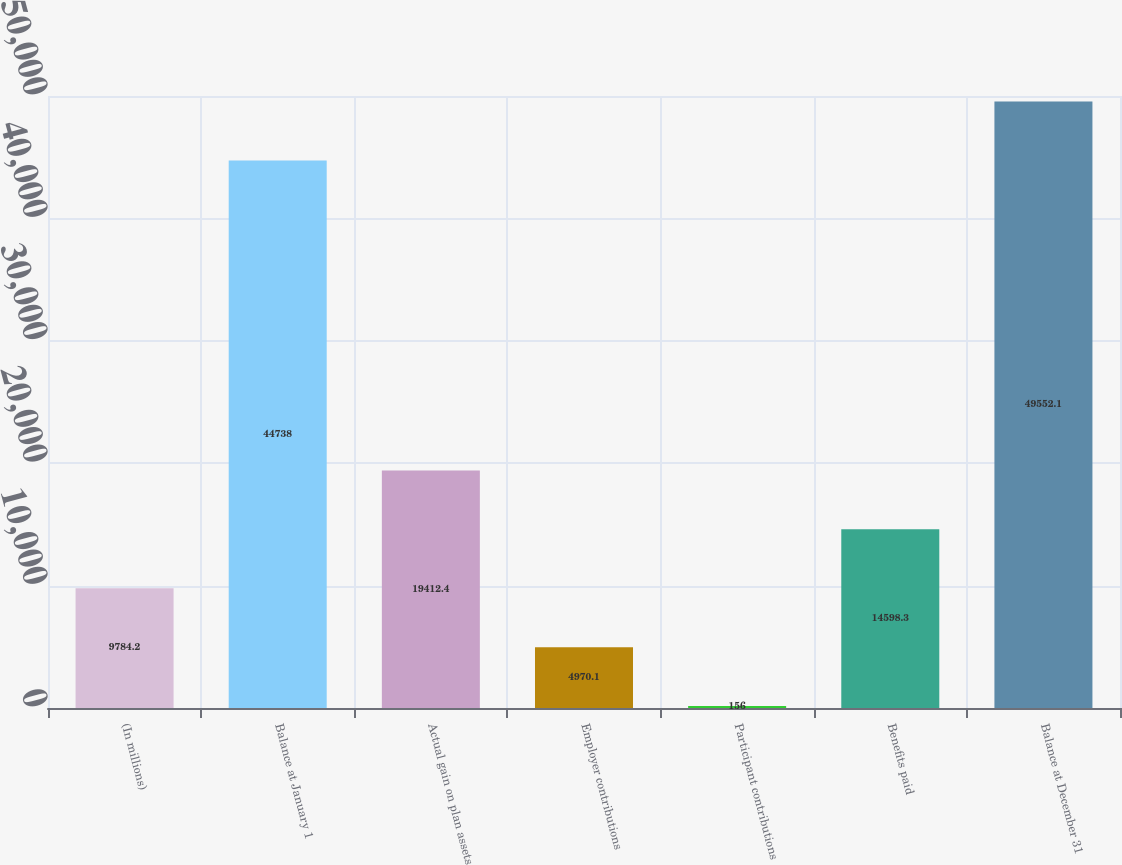Convert chart to OTSL. <chart><loc_0><loc_0><loc_500><loc_500><bar_chart><fcel>(In millions)<fcel>Balance at January 1<fcel>Actual gain on plan assets<fcel>Employer contributions<fcel>Participant contributions<fcel>Benefits paid<fcel>Balance at December 31<nl><fcel>9784.2<fcel>44738<fcel>19412.4<fcel>4970.1<fcel>156<fcel>14598.3<fcel>49552.1<nl></chart> 